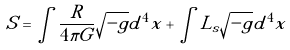Convert formula to latex. <formula><loc_0><loc_0><loc_500><loc_500>S = \int \frac { R } { 4 \pi G } \sqrt { - g } d ^ { 4 } x + \int L _ { s } \sqrt { - g } d ^ { 4 } x</formula> 